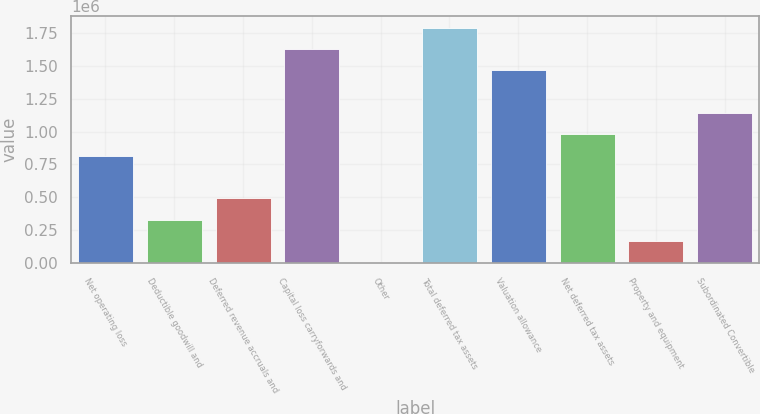Convert chart to OTSL. <chart><loc_0><loc_0><loc_500><loc_500><bar_chart><fcel>Net operating loss<fcel>Deductible goodwill and<fcel>Deferred revenue accruals and<fcel>Capital loss carryforwards and<fcel>Other<fcel>Total deferred tax assets<fcel>Valuation allowance<fcel>Net deferred tax assets<fcel>Property and equipment<fcel>Subordinated Convertible<nl><fcel>816816<fcel>329763<fcel>492114<fcel>1.62857e+06<fcel>5060<fcel>1.79092e+06<fcel>1.46622e+06<fcel>979168<fcel>167411<fcel>1.14152e+06<nl></chart> 